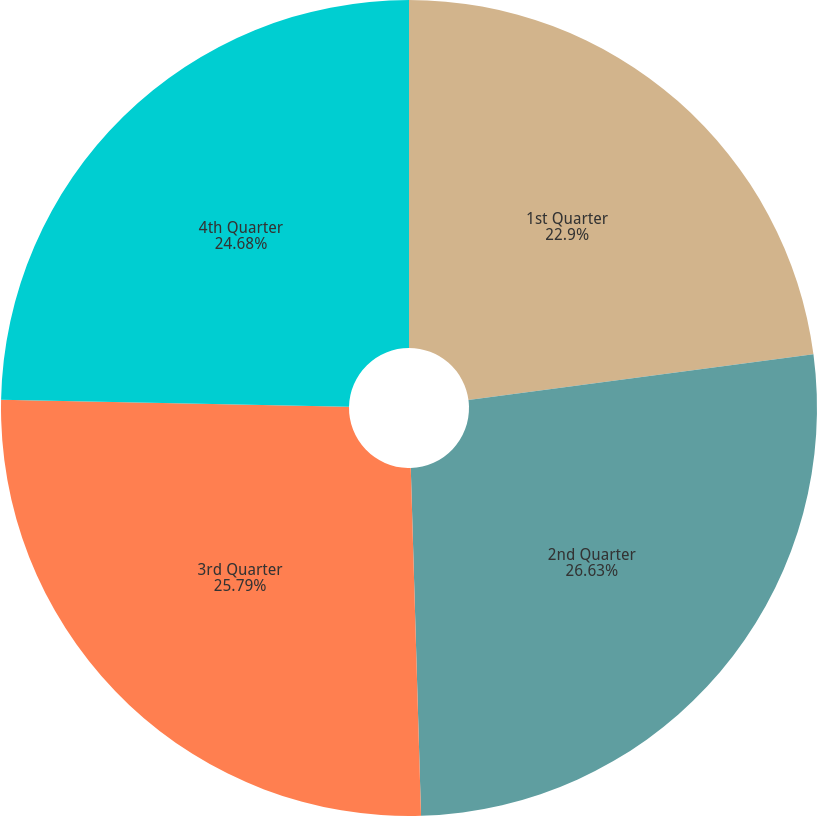Convert chart. <chart><loc_0><loc_0><loc_500><loc_500><pie_chart><fcel>1st Quarter<fcel>2nd Quarter<fcel>3rd Quarter<fcel>4th Quarter<nl><fcel>22.9%<fcel>26.63%<fcel>25.79%<fcel>24.68%<nl></chart> 